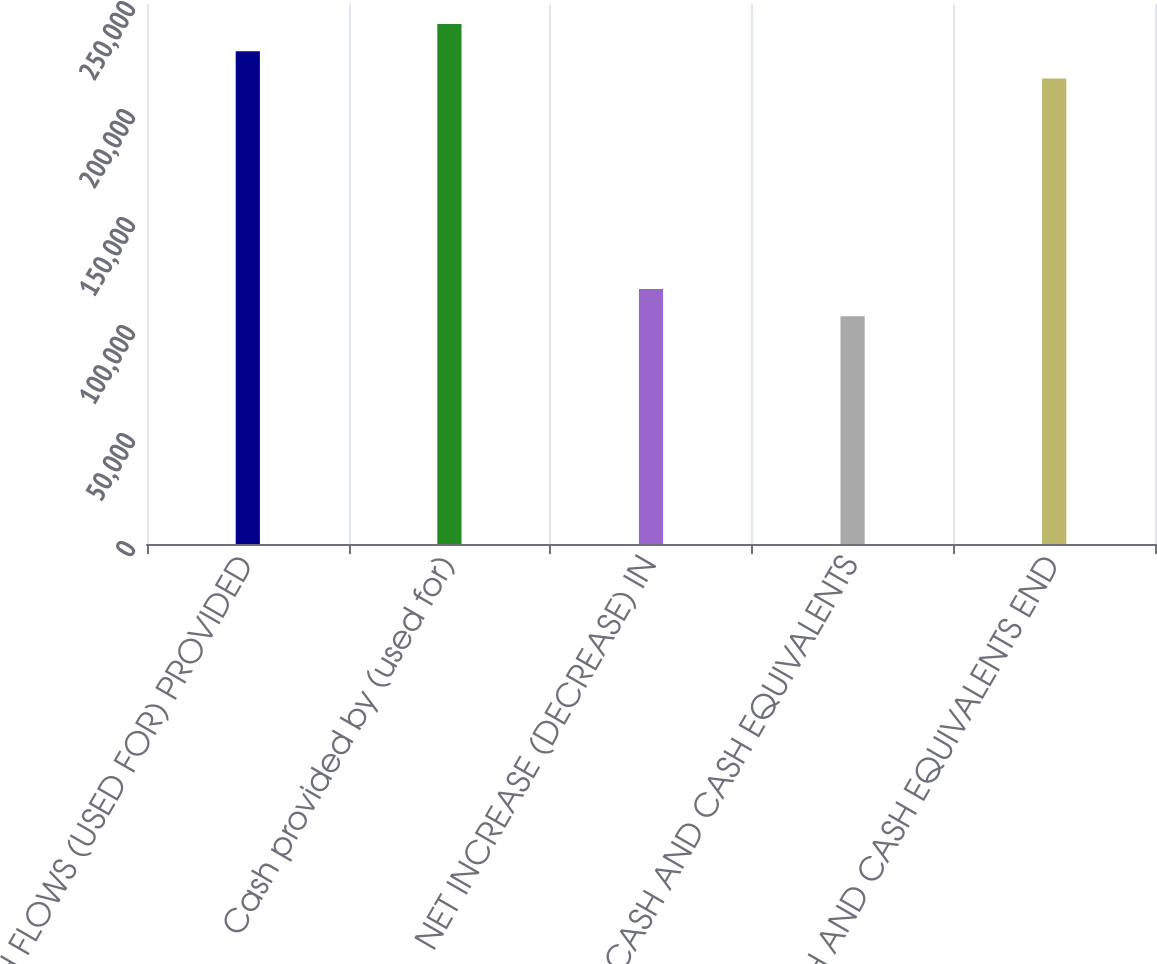Convert chart to OTSL. <chart><loc_0><loc_0><loc_500><loc_500><bar_chart><fcel>CASH FLOWS (USED FOR) PROVIDED<fcel>Cash provided by (used for)<fcel>NET INCREASE (DECREASE) IN<fcel>CASH AND CASH EQUIVALENTS<fcel>CASH AND CASH EQUIVALENTS END<nl><fcel>228153<fcel>240750<fcel>118061<fcel>105465<fcel>215557<nl></chart> 